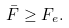<formula> <loc_0><loc_0><loc_500><loc_500>\bar { F } \geq F _ { e } .</formula> 